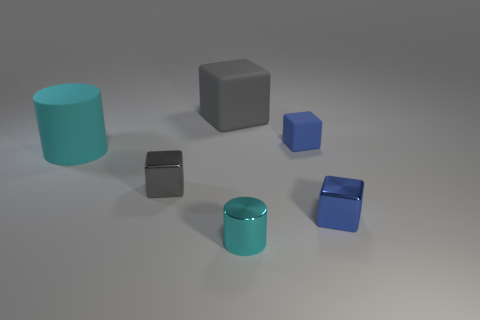Are the objects arranged in a pattern? The objects do not seem to be arranged in a specific pattern; they are spread out randomly across the surface. 